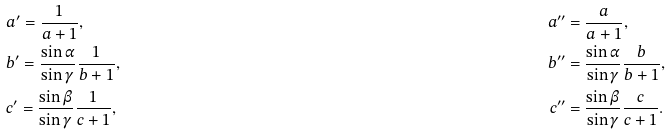Convert formula to latex. <formula><loc_0><loc_0><loc_500><loc_500>& a ^ { \prime } = \frac { 1 } { a + 1 } , & a ^ { \prime \prime } & = \frac { a } { a + 1 } , \\ & b ^ { \prime } = \frac { \sin \alpha } { \sin \gamma } \frac { 1 } { b + 1 } , & b ^ { \prime \prime } & = \frac { \sin \alpha } { \sin \gamma } \frac { b } { b + 1 } , \\ & c ^ { \prime } = \frac { \sin \beta } { \sin \gamma } \frac { 1 } { c + 1 } , & c ^ { \prime \prime } & = \frac { \sin \beta } { \sin \gamma } \frac { c } { c + 1 } . \\</formula> 